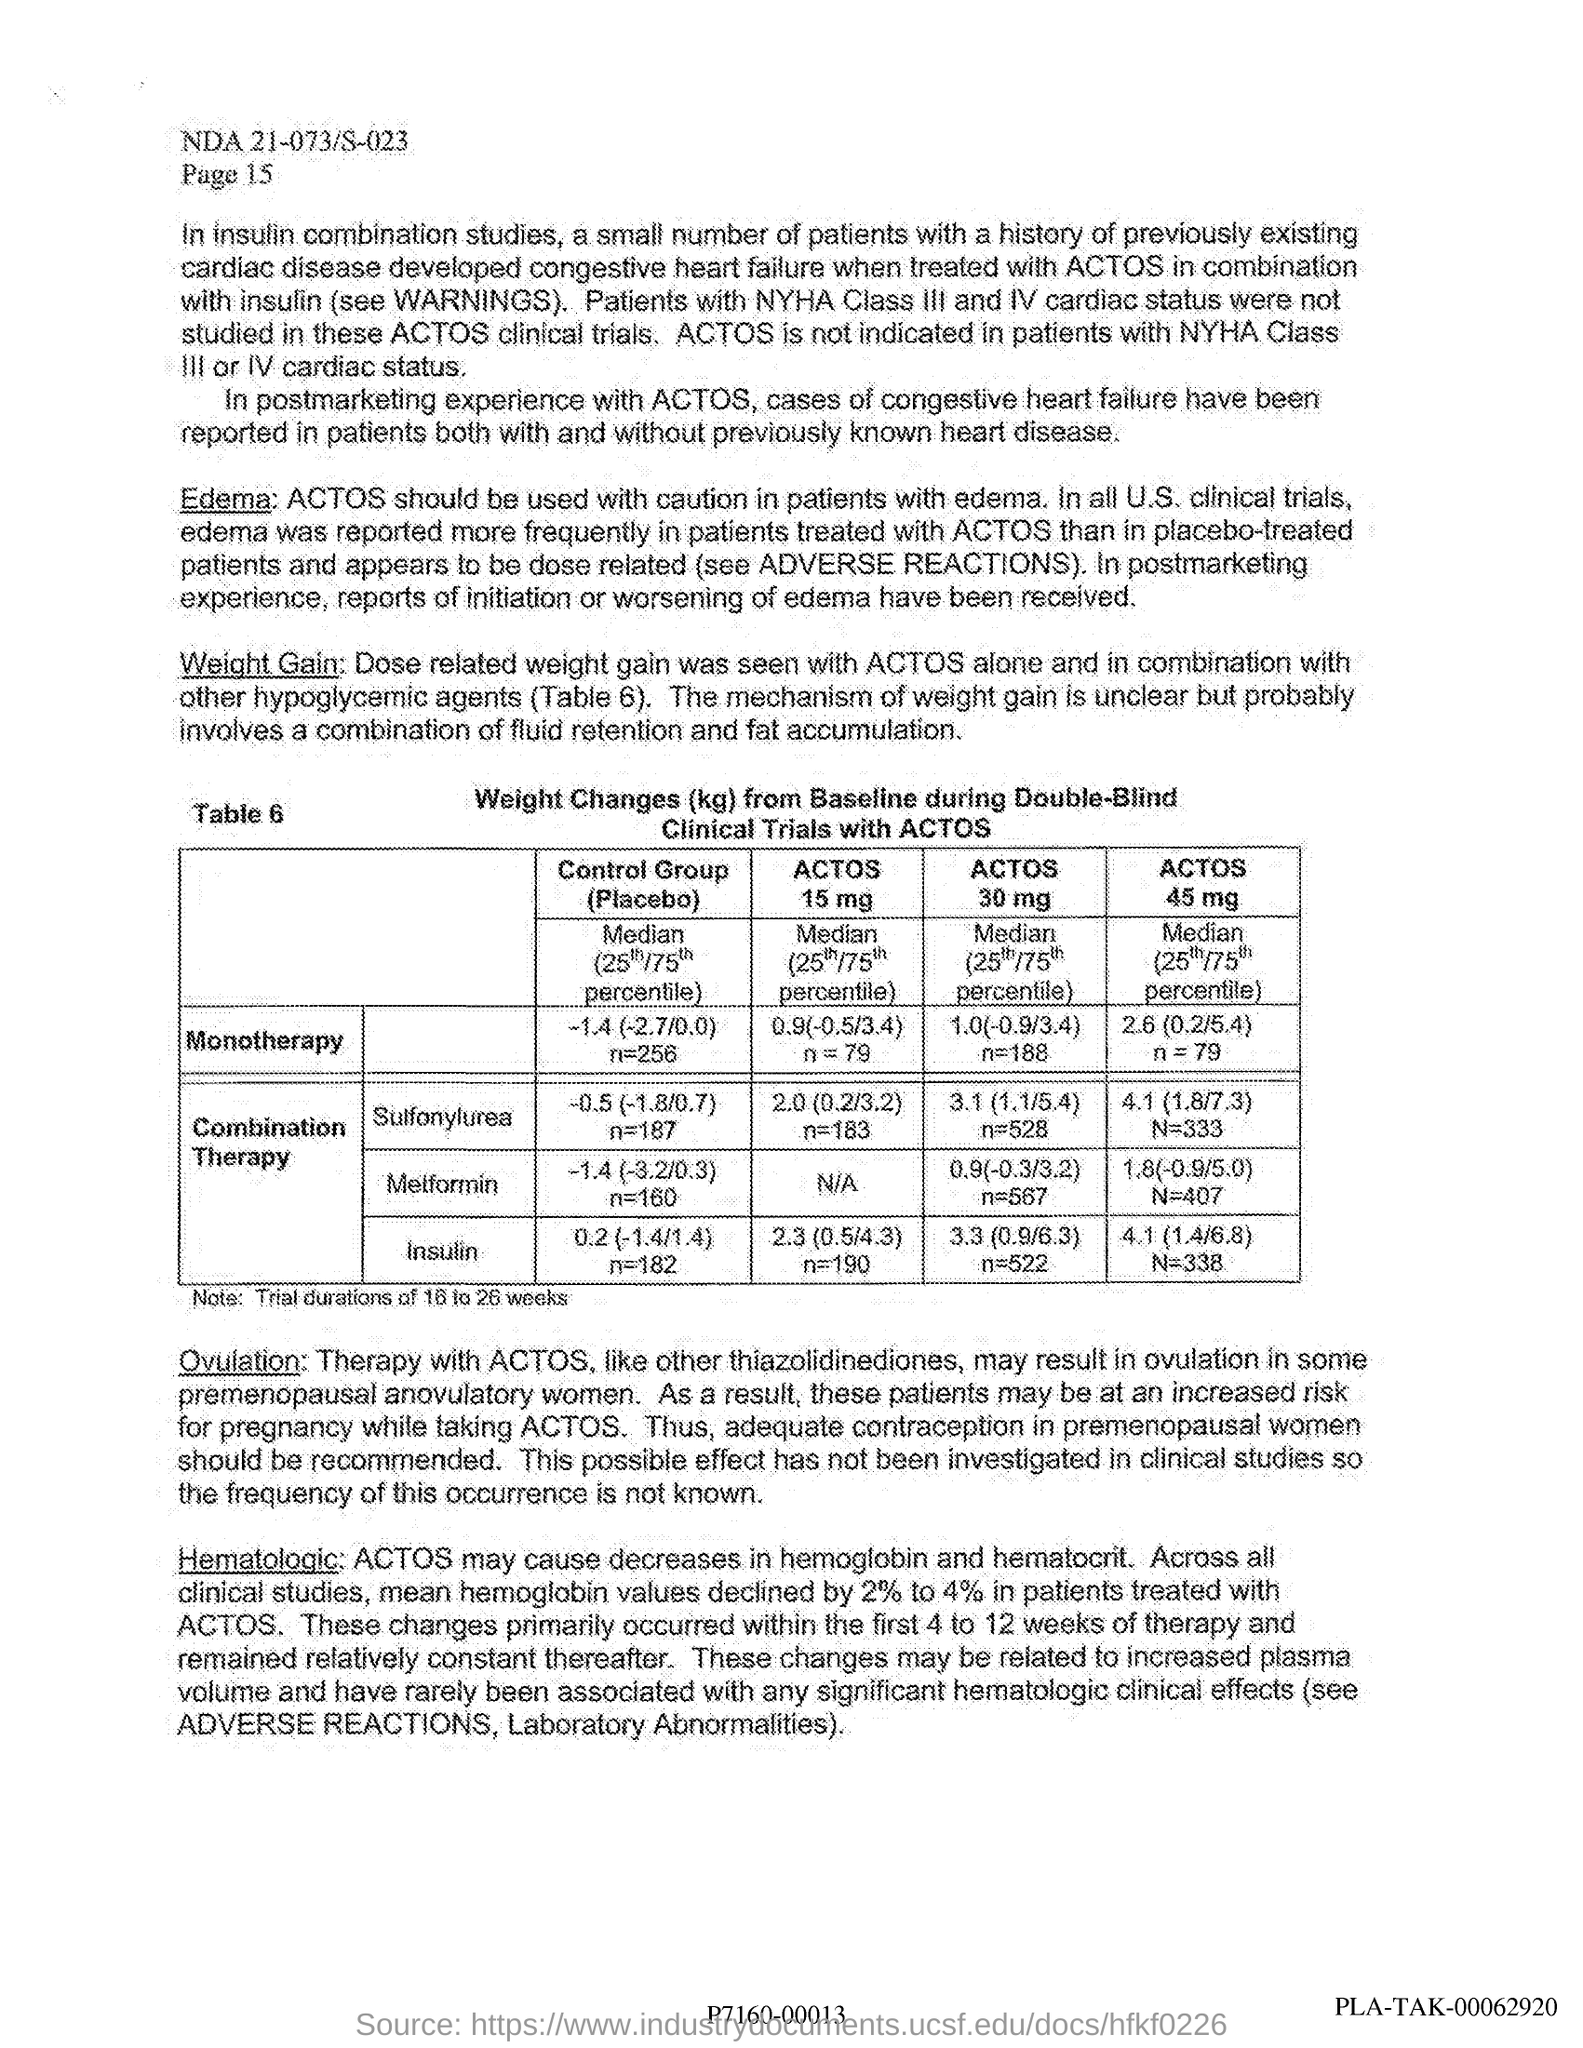Point out several critical features in this image. The trial duration is 16 to 26 weeks. The combination therapy of insulin with ACTOS 45 mg resulted in a decrease in hemoglobin A1c (HbA1c) of 0.79% in patients, with a 4.1% reduction in fasting plasma glucose (FPG) and a 6.8% reduction in postprandial plasma glucose (PPG), as compared to baseline. The ACTOS monotherapy dose of 15 mg was found to be 0.9 (-0.5/3.4) in a study involving 79 participants. The heading of the table provides the weight changes (in kg) from the baseline during double-blind clinical trials with ACTOS. 